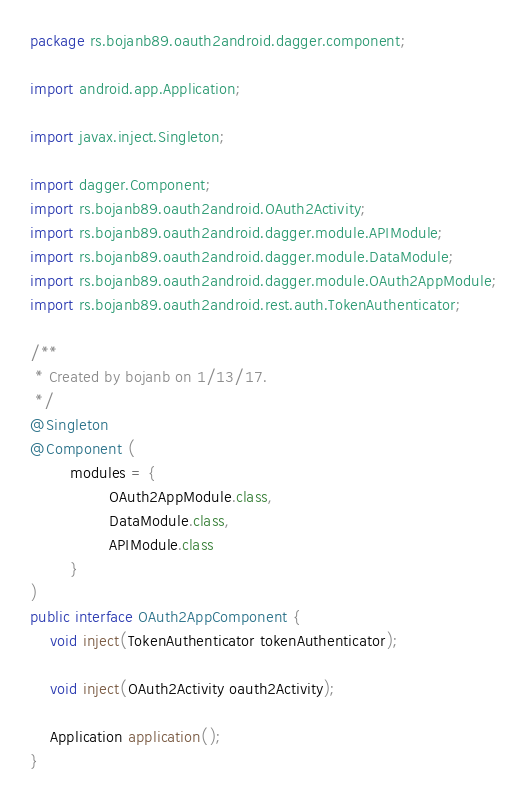<code> <loc_0><loc_0><loc_500><loc_500><_Java_>package rs.bojanb89.oauth2android.dagger.component;

import android.app.Application;

import javax.inject.Singleton;

import dagger.Component;
import rs.bojanb89.oauth2android.OAuth2Activity;
import rs.bojanb89.oauth2android.dagger.module.APIModule;
import rs.bojanb89.oauth2android.dagger.module.DataModule;
import rs.bojanb89.oauth2android.dagger.module.OAuth2AppModule;
import rs.bojanb89.oauth2android.rest.auth.TokenAuthenticator;

/**
 * Created by bojanb on 1/13/17.
 */
@Singleton
@Component (
        modules = {
                OAuth2AppModule.class,
                DataModule.class,
                APIModule.class
        }
)
public interface OAuth2AppComponent {
    void inject(TokenAuthenticator tokenAuthenticator);

    void inject(OAuth2Activity oauth2Activity);

    Application application();
}
</code> 